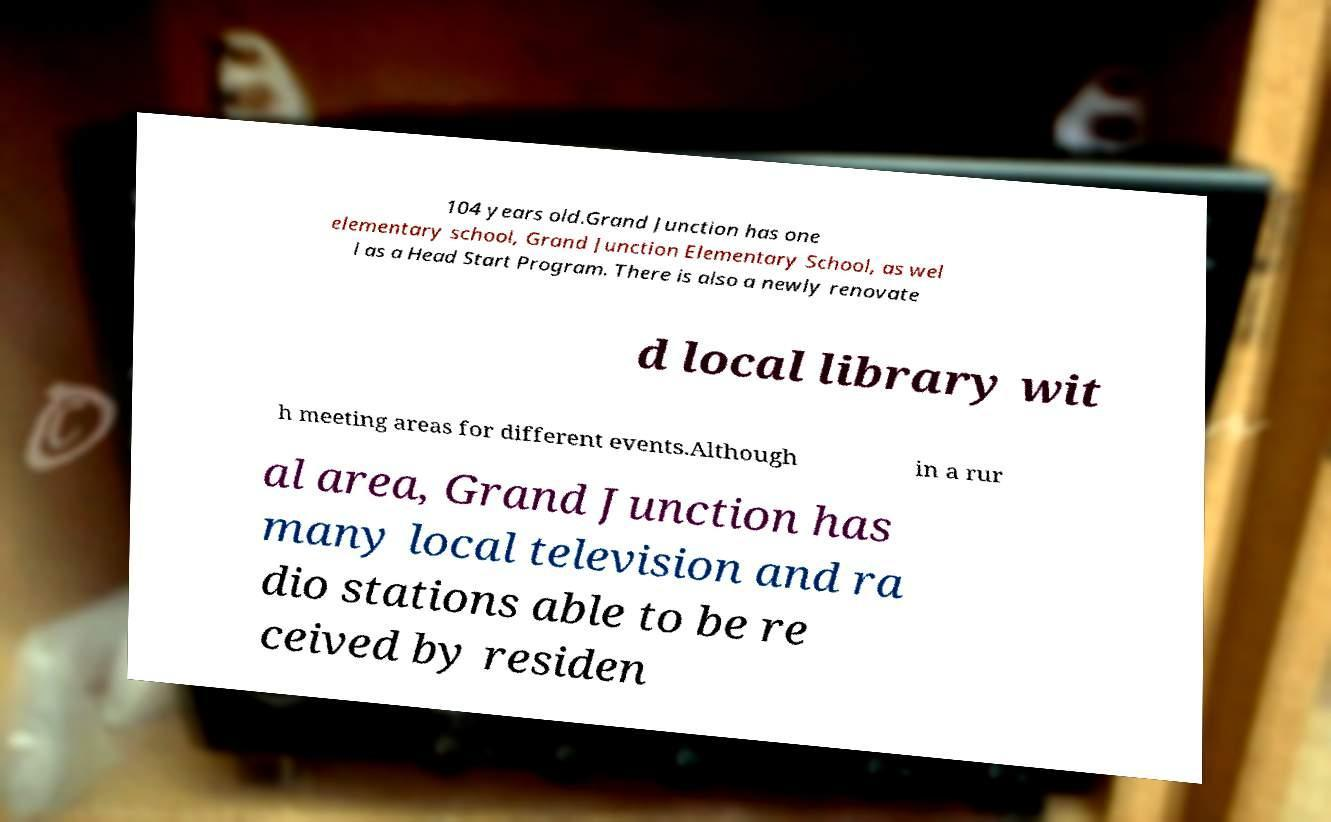Can you accurately transcribe the text from the provided image for me? 104 years old.Grand Junction has one elementary school, Grand Junction Elementary School, as wel l as a Head Start Program. There is also a newly renovate d local library wit h meeting areas for different events.Although in a rur al area, Grand Junction has many local television and ra dio stations able to be re ceived by residen 